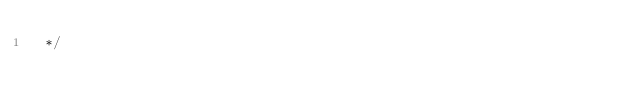Convert code to text. <code><loc_0><loc_0><loc_500><loc_500><_CSS_> */</code> 